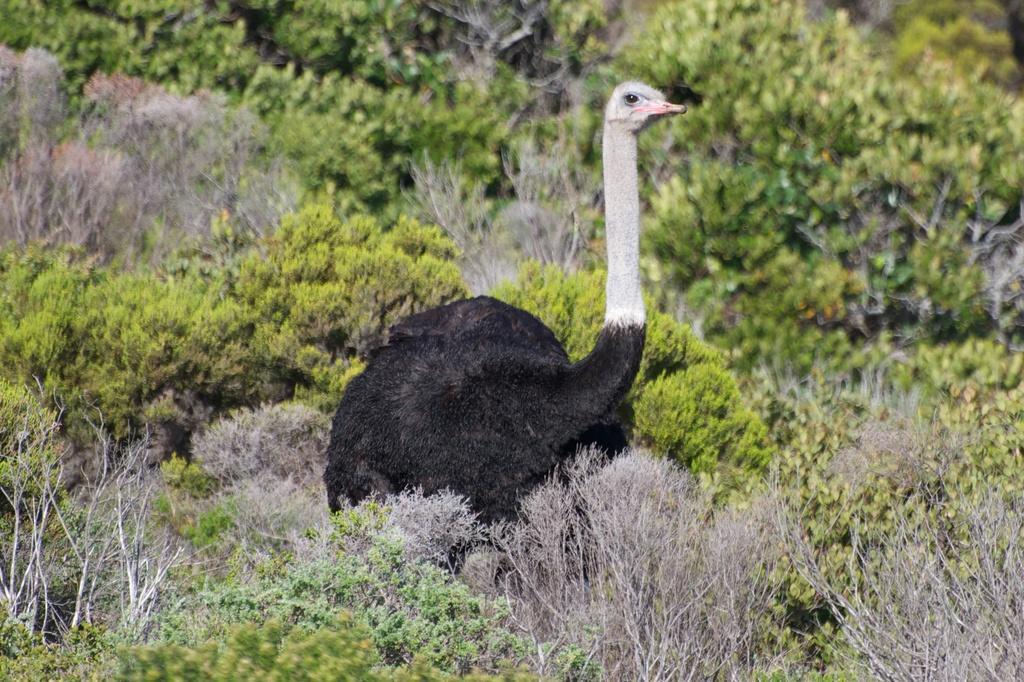Please provide a concise description of this image. In this picture we can see the ostrich which is standing near to the plants. In the background we can see the trees. 